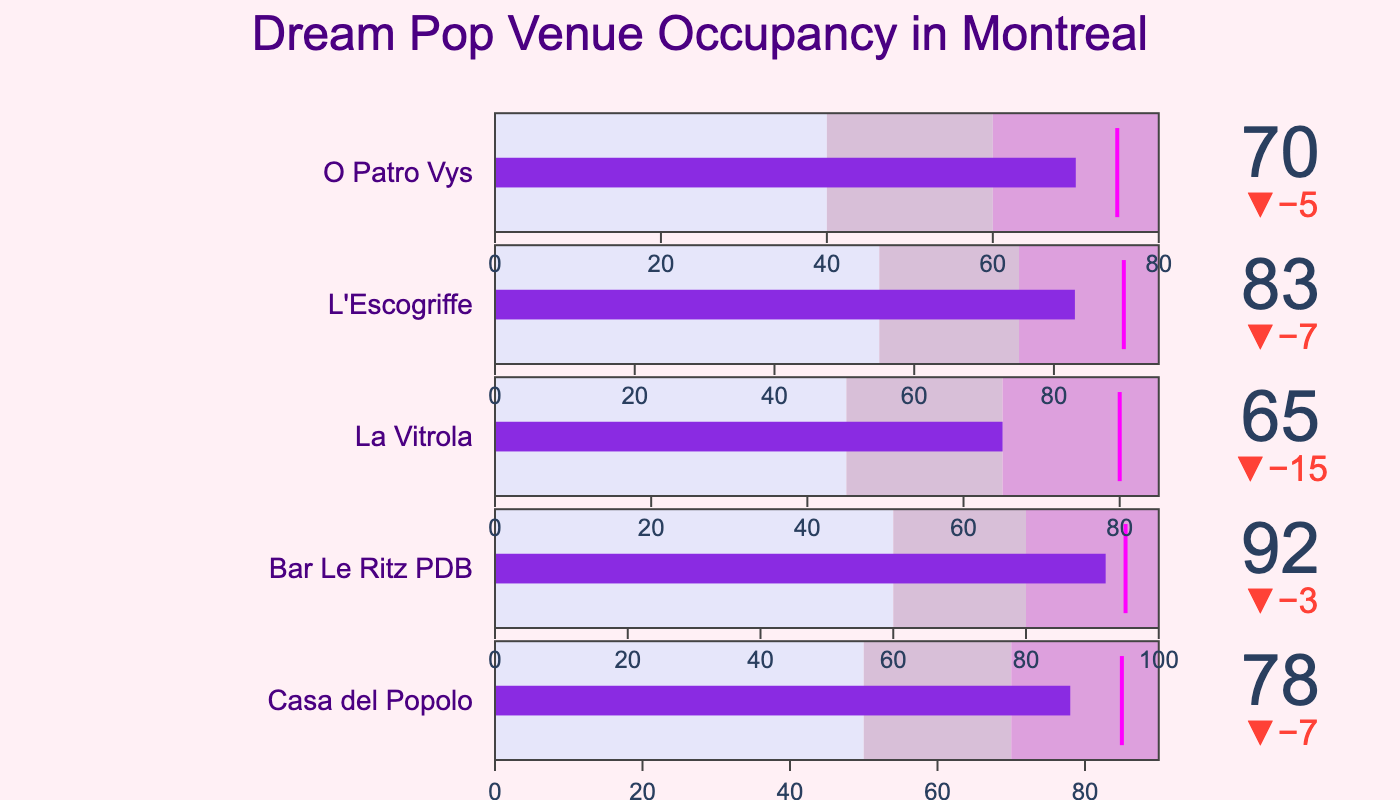How many music venues are listed in the figure? There are five distinct music venues listed in the title column of the dataset.
Answer: Five What is the figure's main title? The main title is prominently displayed at the top of the figure.
Answer: Dream Pop Venue Occupancy in Montreal What is the actual occupancy rate of Casa del Popolo? The actual occupancy rate can be seen in the bullet chart for Casa del Popolo, which shows a value of 78.
Answer: 78 Which venue has the highest occupancy rate? By examining the actual values for each venue, Bar Le Ritz PDB has the highest occupancy rate with a value of 92.
Answer: Bar Le Ritz PDB Which venue is closest to reaching its target occupancy rate? By comparing the actual values to the target values for each venue, Casa del Popolo is closest to its target with only 7 units below its target of 85 (actual of 78).
Answer: Casa del Popolo How many venues have actual occupancy rates below their target? Compare the actual and target rates; all five venues have actual occupancy rates below their targets.
Answer: Five What is the color used to represent the highest performance range in the gauges? The highest performance range is the last range colored on the bars, which appears light purple.
Answer: Light purple What venue has the smallest difference between actual and target occupancy rates? Subtracting the actual from the target for each venue: Casa del Popolo (85-78=7), Bar Le Ritz PDB (95-92=3), La Vitrola (80-65=15), L'Escogriffe (90-83=7), O Patro Vys (75-70=5). Bar Le Ritz PDB has the smallest difference with 3.
Answer: Bar Le Ritz PDB Which venue is represented in the bottom indicator of the figure? The bottom indicator, based on the data provided, corresponds to O Patro Vys.
Answer: O Patro Vys Excluding the highest performing venue, what is the aggregate occupancy rate of the remaining four venues? Add the actual values of the four remaining venues: Casa del Popolo (78), La Vitrola (65), L'Escogriffe (83), O Patro Vys (70). The sum is 78 + 65 + 83 + 70 = 296.
Answer: 296 